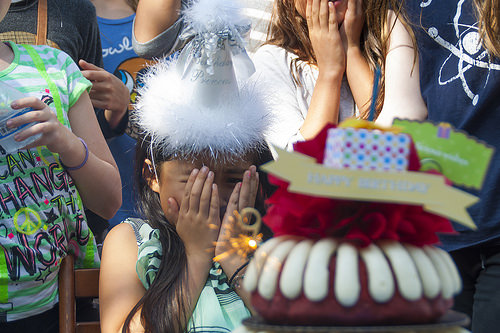<image>
Is the girl to the left of the hat? No. The girl is not to the left of the hat. From this viewpoint, they have a different horizontal relationship. 